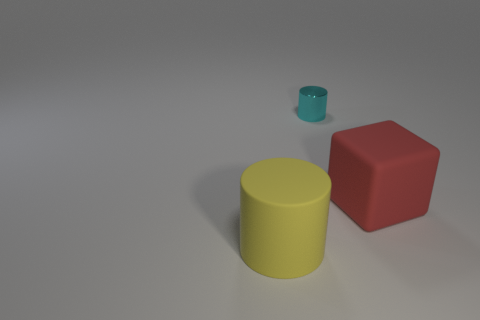What is the color of the large thing right of the large cylinder?
Ensure brevity in your answer.  Red. Is there any other thing that is the same color as the large cylinder?
Give a very brief answer. No. Do the yellow object and the red matte thing have the same size?
Your answer should be compact. Yes. There is a object that is both in front of the small metal thing and behind the yellow thing; what is its size?
Offer a very short reply. Large. What number of cyan cylinders have the same material as the cyan thing?
Make the answer very short. 0. The big rubber cube is what color?
Give a very brief answer. Red. Is the shape of the matte thing that is to the left of the large red thing the same as  the red rubber object?
Offer a terse response. No. How many things are rubber things that are right of the small cyan metal object or large blocks?
Ensure brevity in your answer.  1. Are there any other objects of the same shape as the yellow rubber thing?
Your answer should be compact. Yes. There is a yellow rubber object that is the same size as the red rubber object; what shape is it?
Offer a very short reply. Cylinder. 